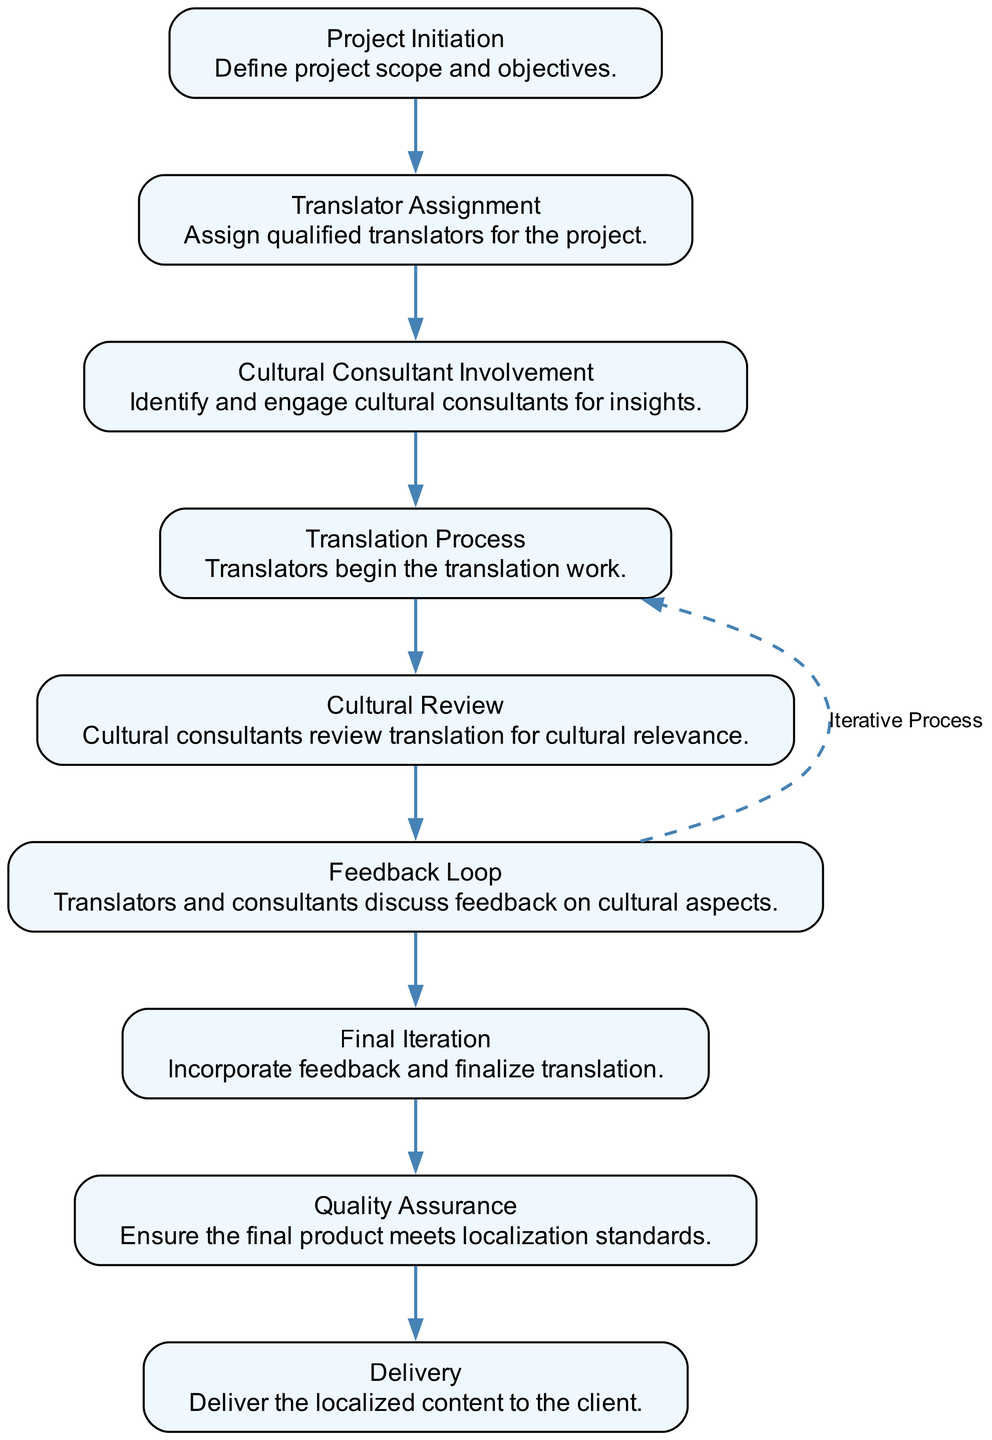What is the first step in the collaboration process? The first step in the flow chart is "Project Initiation," where the project scope and objectives are defined.
Answer: Project Initiation How many nodes are in the diagram? The diagram has a total of nine nodes representing different stages in the collaboration process.
Answer: Nine Which node follows the "Translator Assignment"? The node that follows "Translator Assignment" is "Cultural Consultant Involvement," indicating that cultural consultants are to be engaged next.
Answer: Cultural Consultant Involvement What type of process is indicated by the dashed line between two nodes? The dashed line represents the "Feedback Loop," indicating an iterative process where translators and consultants discuss feedback on cultural aspects.
Answer: Feedback Loop What is the last step before delivery? Before the delivery of the localized content, the final step is "Quality Assurance," which ensures that the final product meets localization standards.
Answer: Quality Assurance How many edges are originating from the "Cultural Review" node? There are two edges originating from the "Cultural Review" node; one leads to "Feedback Loop" and the other leads to "Final Iteration."
Answer: Two What is the meaning of the edge from "Feedback Loop" to "Translation Process"? This edge denotes an iterative process where translators may need to revisit the "Translation Process" after receiving feedback from the cultural review.
Answer: Iterative Process What step follows "Final Iteration"? The step that follows "Final Iteration" is "Quality Assurance," where the translation undergoes final checks against localization standards.
Answer: Quality Assurance What kind of consultants are involved in the process? The flow chart specifically mentions "Cultural Consultants," indicating their role is to provide insights related to cultural relevance in the translation.
Answer: Cultural Consultants 